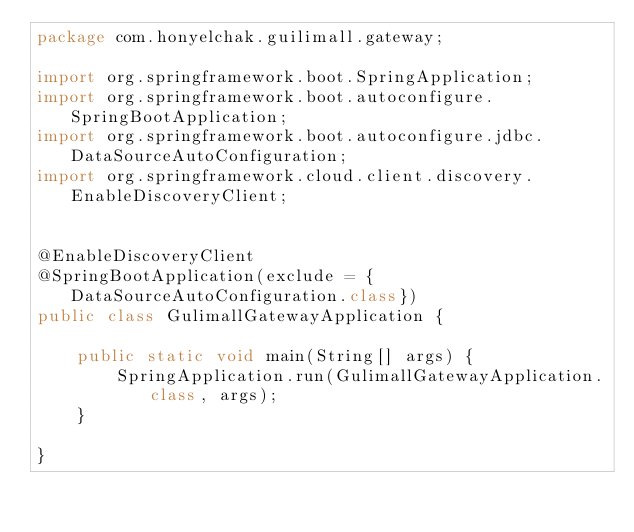Convert code to text. <code><loc_0><loc_0><loc_500><loc_500><_Java_>package com.honyelchak.guilimall.gateway;

import org.springframework.boot.SpringApplication;
import org.springframework.boot.autoconfigure.SpringBootApplication;
import org.springframework.boot.autoconfigure.jdbc.DataSourceAutoConfiguration;
import org.springframework.cloud.client.discovery.EnableDiscoveryClient;


@EnableDiscoveryClient
@SpringBootApplication(exclude = {DataSourceAutoConfiguration.class})
public class GulimallGatewayApplication {

    public static void main(String[] args) {
        SpringApplication.run(GulimallGatewayApplication.class, args);
    }

}
</code> 